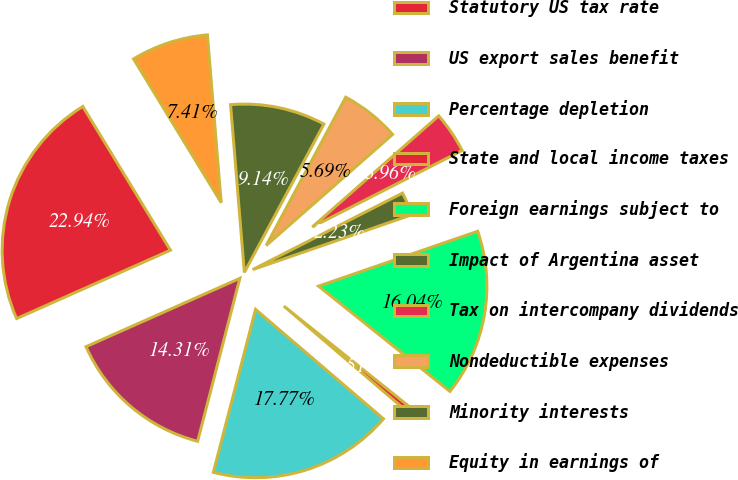Convert chart to OTSL. <chart><loc_0><loc_0><loc_500><loc_500><pie_chart><fcel>Statutory US tax rate<fcel>US export sales benefit<fcel>Percentage depletion<fcel>State and local income taxes<fcel>Foreign earnings subject to<fcel>Impact of Argentina asset<fcel>Tax on intercompany dividends<fcel>Nondeductible expenses<fcel>Minority interests<fcel>Equity in earnings of<nl><fcel>22.94%<fcel>14.31%<fcel>17.77%<fcel>0.51%<fcel>16.04%<fcel>2.23%<fcel>3.96%<fcel>5.69%<fcel>9.14%<fcel>7.41%<nl></chart> 